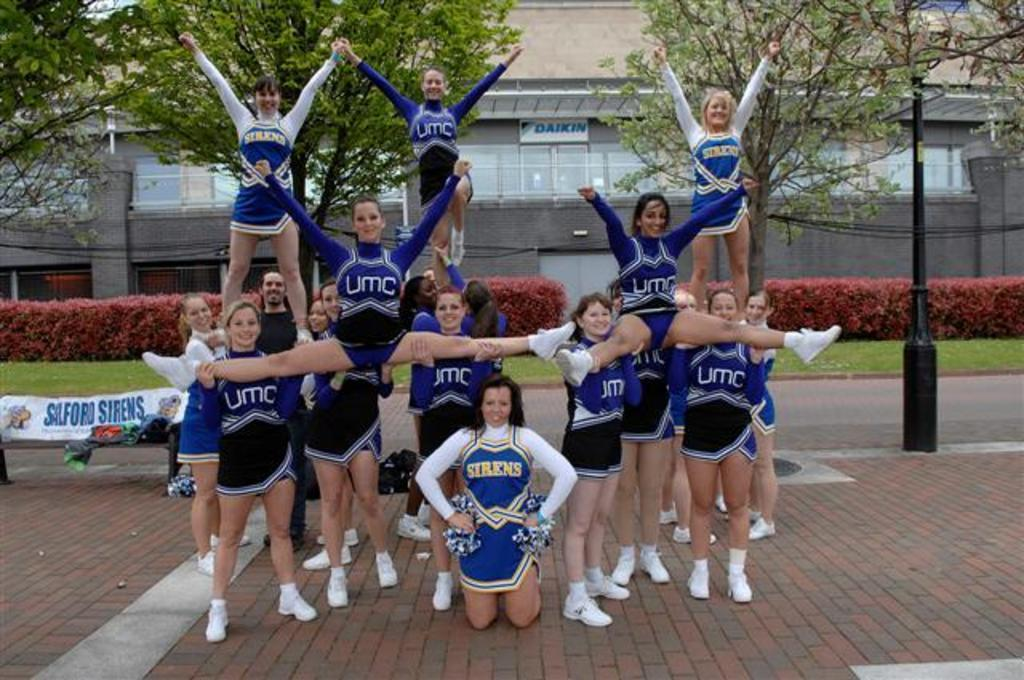<image>
Write a terse but informative summary of the picture. some Sirens cheerleaders that are playing with each other 